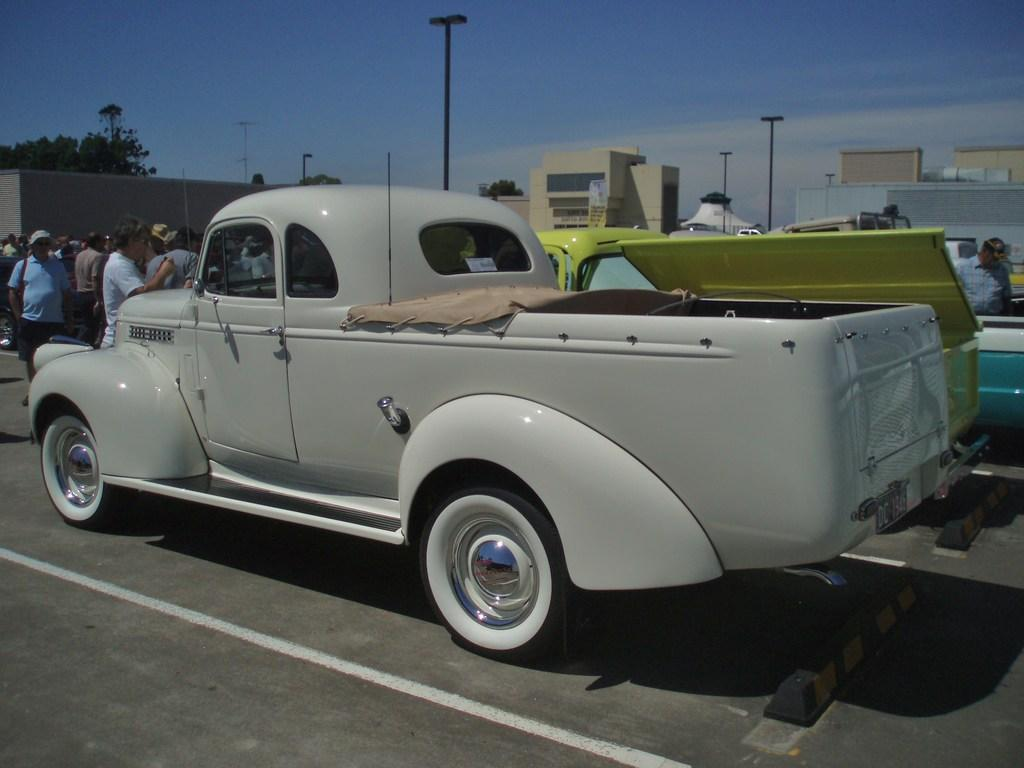What types of objects can be seen in the image? There are vehicles and people in the image. What can be seen in the background of the image? There are buildings, poles, trees, and the sky visible in the background of the image. Are there any other objects present in the background? Yes, there are other objects in the background of the image. What type of coal is being used by the lawyer during the recess in the image? There is no coal, lawyer, or recess present in the image. 